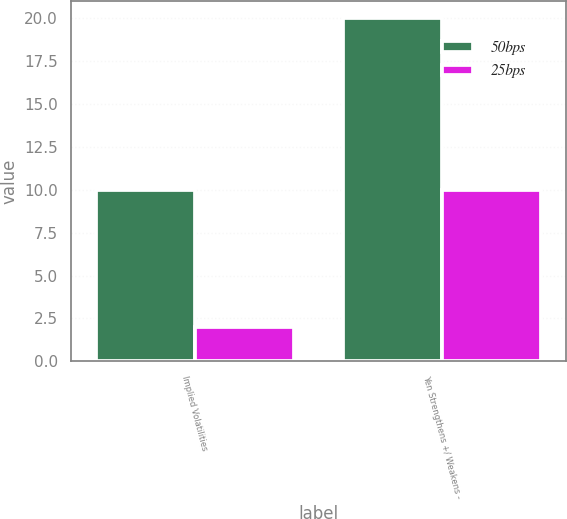Convert chart. <chart><loc_0><loc_0><loc_500><loc_500><stacked_bar_chart><ecel><fcel>Implied Volatilities<fcel>Yen Strengthens +/ Weakens -<nl><fcel>50bps<fcel>10<fcel>20<nl><fcel>25bps<fcel>2<fcel>10<nl></chart> 